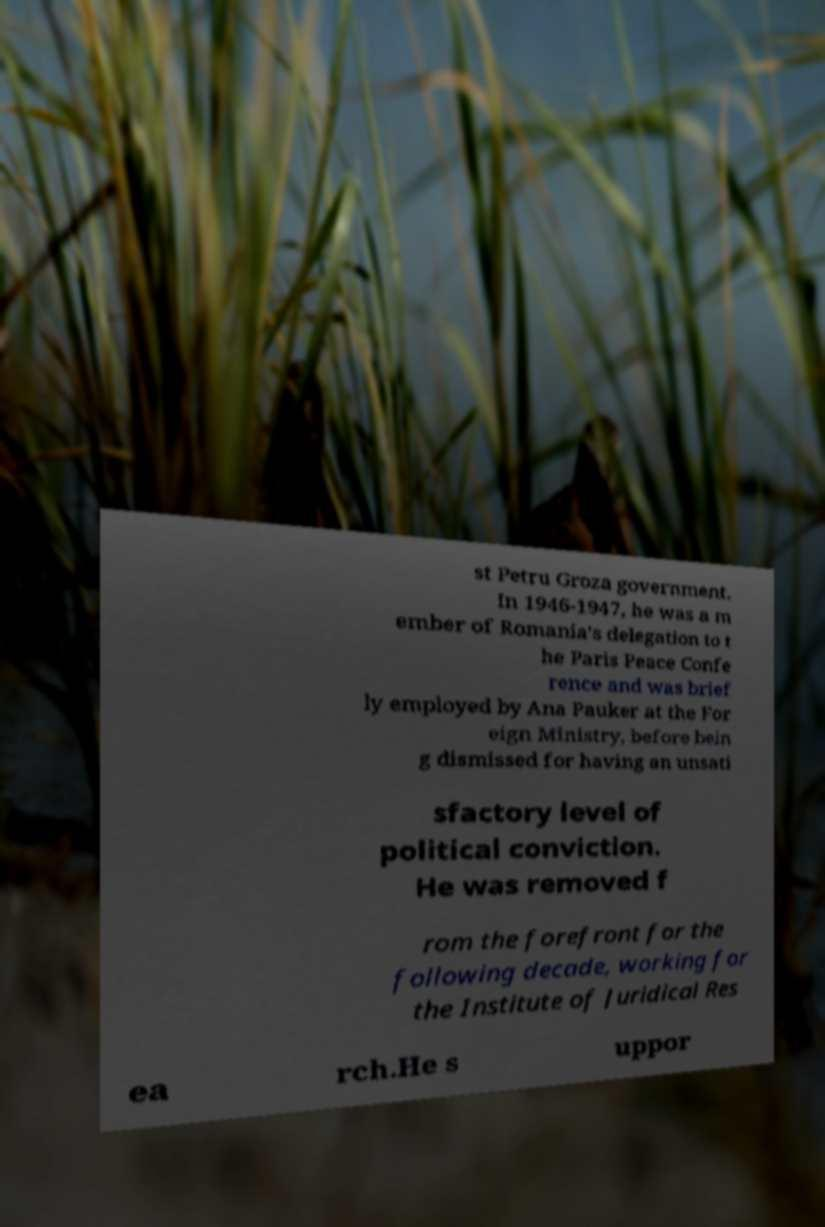Please read and relay the text visible in this image. What does it say? st Petru Groza government. In 1946-1947, he was a m ember of Romania's delegation to t he Paris Peace Confe rence and was brief ly employed by Ana Pauker at the For eign Ministry, before bein g dismissed for having an unsati sfactory level of political conviction. He was removed f rom the forefront for the following decade, working for the Institute of Juridical Res ea rch.He s uppor 